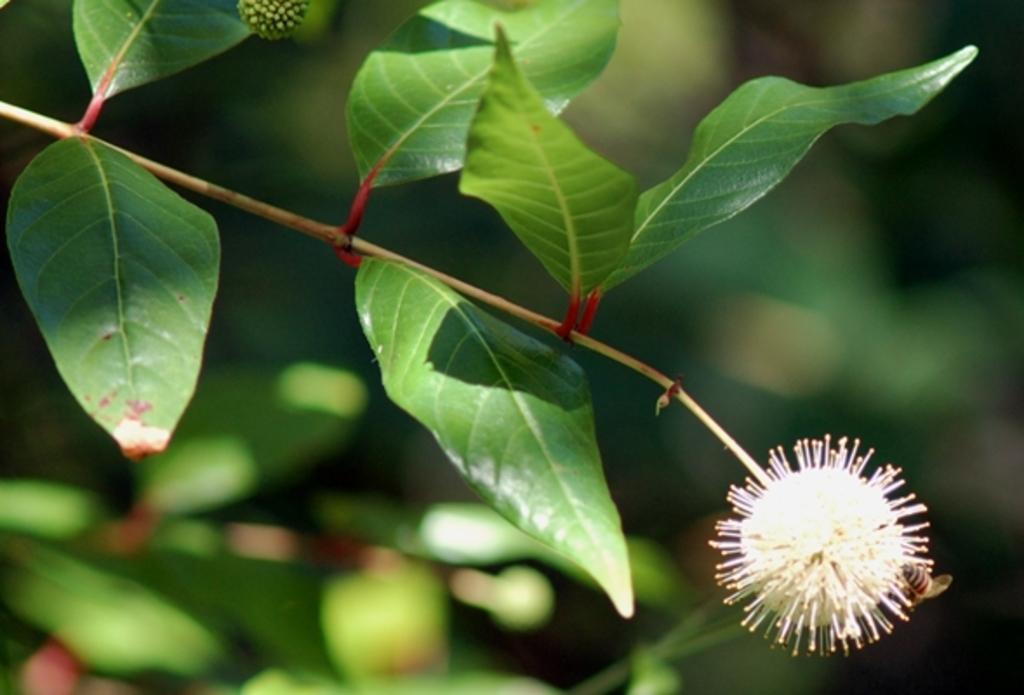How would you summarize this image in a sentence or two? In this image, we can see the Buttonbush and the background is blurred. We can also see an insect. 